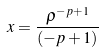Convert formula to latex. <formula><loc_0><loc_0><loc_500><loc_500>x = \frac { \rho ^ { - p + 1 } } { ( - p + 1 ) }</formula> 